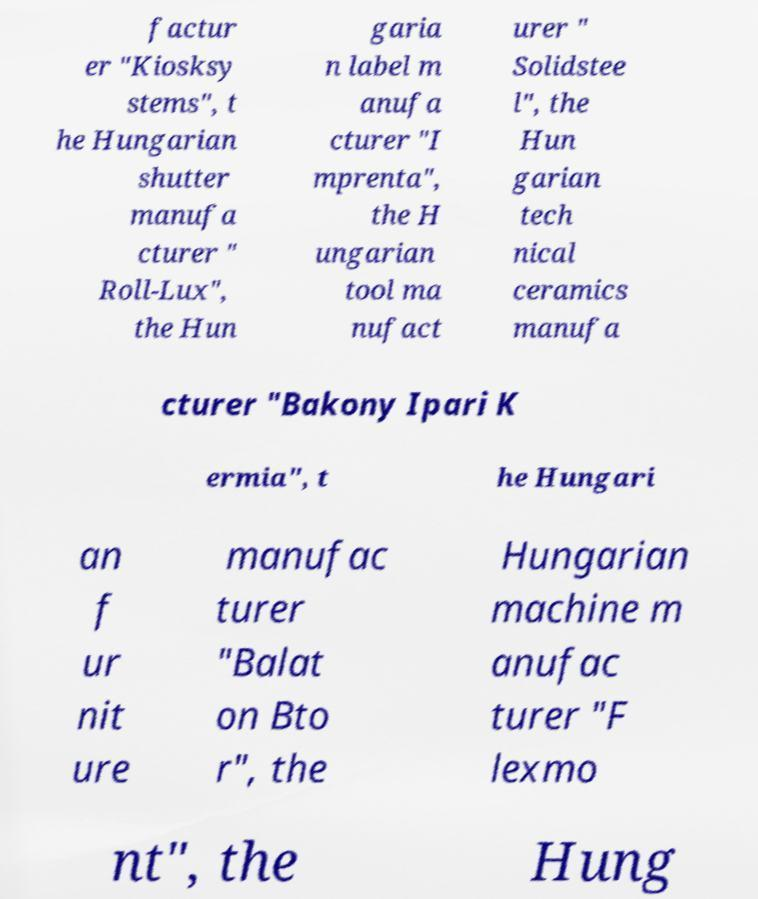Can you accurately transcribe the text from the provided image for me? factur er "Kiosksy stems", t he Hungarian shutter manufa cturer " Roll-Lux", the Hun garia n label m anufa cturer "I mprenta", the H ungarian tool ma nufact urer " Solidstee l", the Hun garian tech nical ceramics manufa cturer "Bakony Ipari K ermia", t he Hungari an f ur nit ure manufac turer "Balat on Bto r", the Hungarian machine m anufac turer "F lexmo nt", the Hung 